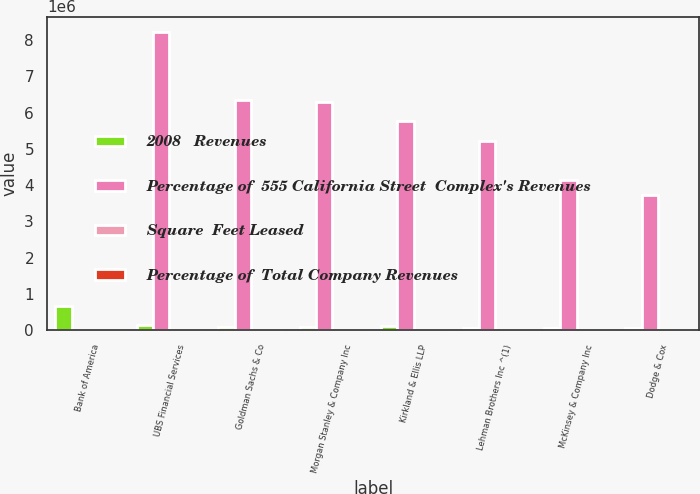<chart> <loc_0><loc_0><loc_500><loc_500><stacked_bar_chart><ecel><fcel>Bank of America<fcel>UBS Financial Services<fcel>Goldman Sachs & Co<fcel>Morgan Stanley & Company Inc<fcel>Kirkland & Ellis LLP<fcel>Lehman Brothers Inc ^(1)<fcel>McKinsey & Company Inc<fcel>Dodge & Cox<nl><fcel>2008   Revenues<fcel>659000<fcel>134000<fcel>97000<fcel>89000<fcel>125000<fcel>61000<fcel>54000<fcel>62000<nl><fcel>Percentage of  555 California Street  Complex's Revenues<fcel>33.2<fcel>8.232e+06<fcel>6.342e+06<fcel>6.291e+06<fcel>5.773e+06<fcel>5.212e+06<fcel>4.143e+06<fcel>3.736e+06<nl><fcel>Square  Feet Leased<fcel>33.2<fcel>7.5<fcel>5.8<fcel>5.7<fcel>5.3<fcel>4.7<fcel>3.8<fcel>3.4<nl><fcel>Percentage of  Total Company Revenues<fcel>1.3<fcel>0.3<fcel>0.2<fcel>0.2<fcel>0.2<fcel>0.2<fcel>0.2<fcel>0.1<nl></chart> 